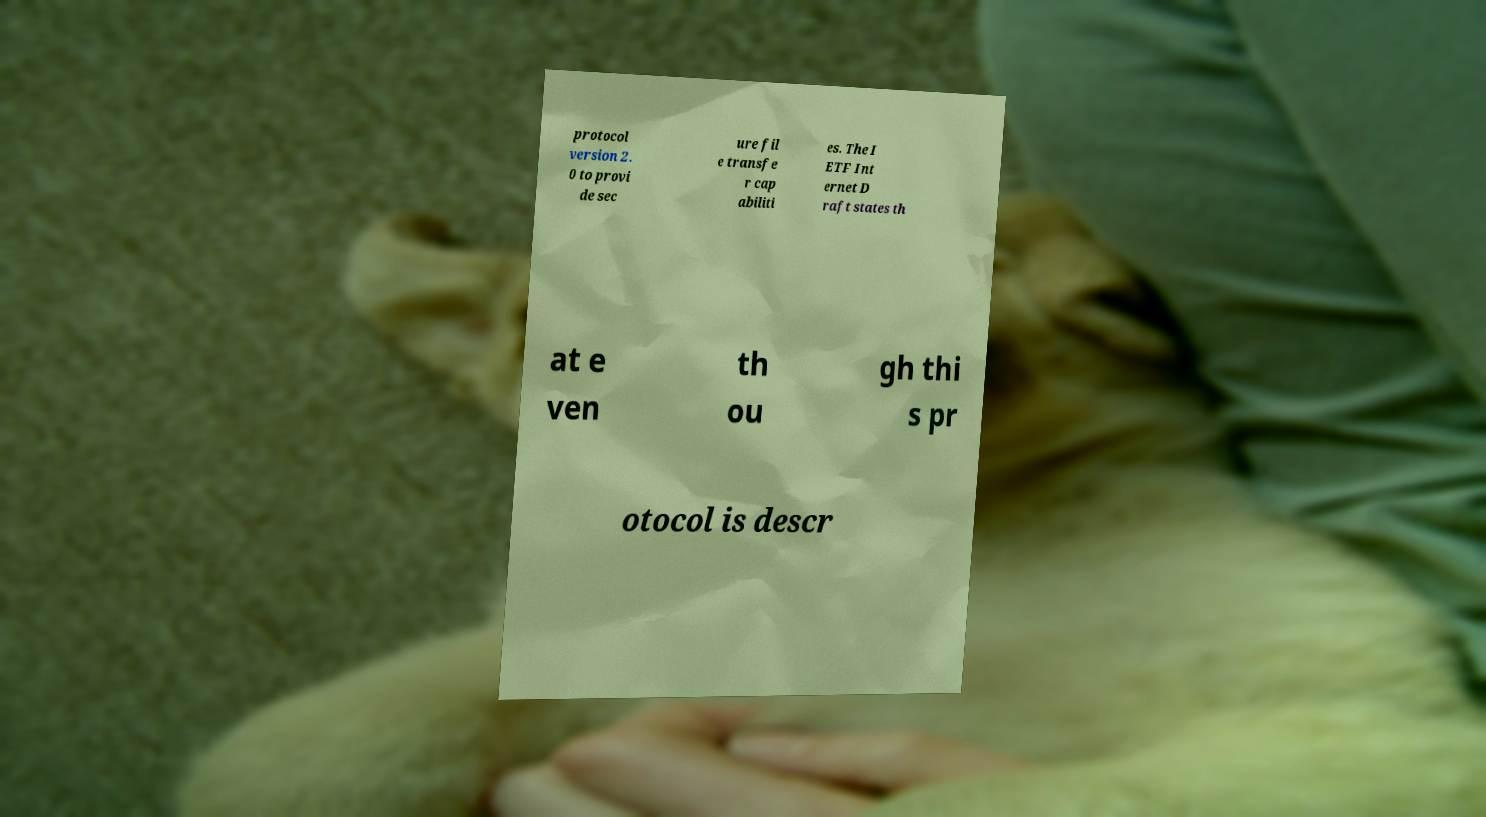Please read and relay the text visible in this image. What does it say? protocol version 2. 0 to provi de sec ure fil e transfe r cap abiliti es. The I ETF Int ernet D raft states th at e ven th ou gh thi s pr otocol is descr 